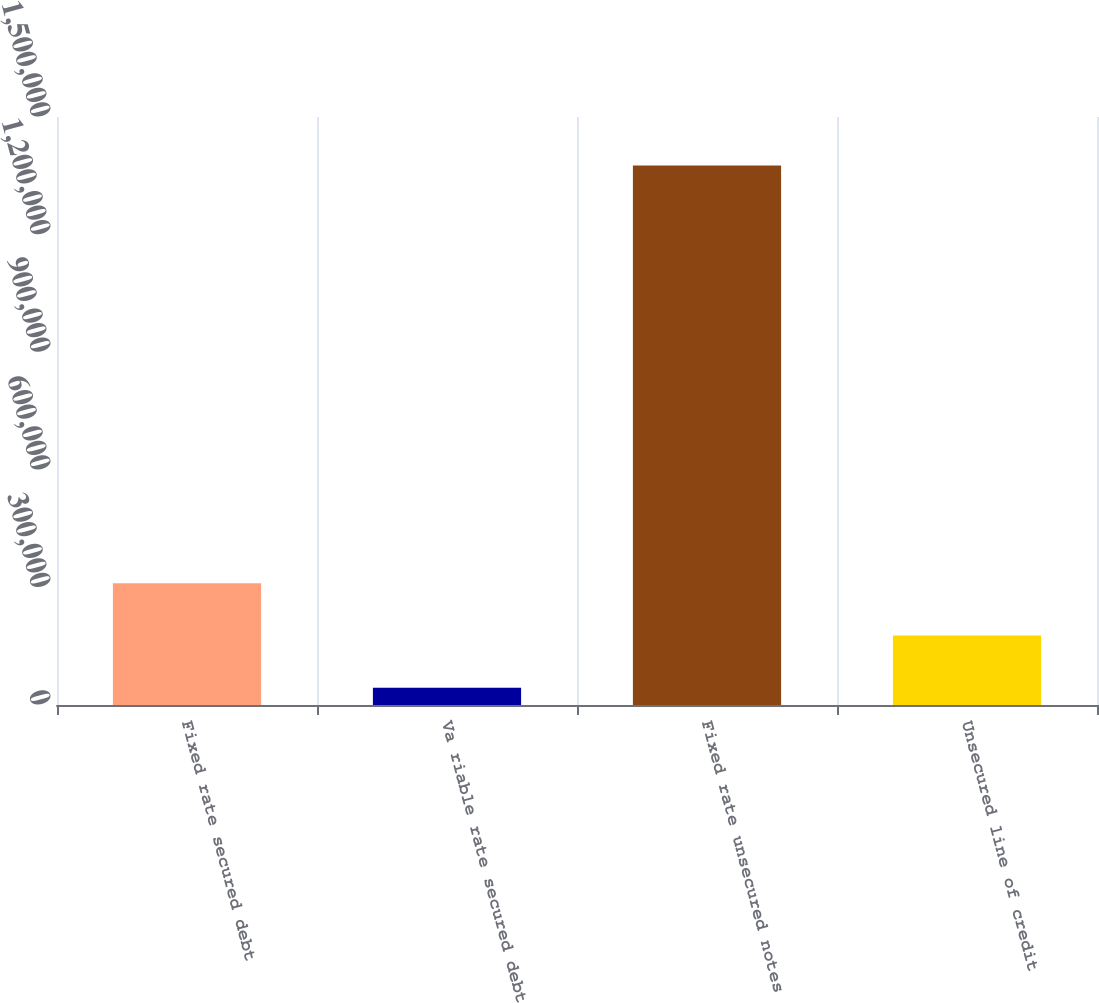Convert chart. <chart><loc_0><loc_0><loc_500><loc_500><bar_chart><fcel>Fixed rate secured debt<fcel>Va riable rate secured debt<fcel>Fixed rate unsecured notes<fcel>Unsecured line of credit<nl><fcel>310575<fcel>44126<fcel>1.37637e+06<fcel>177351<nl></chart> 